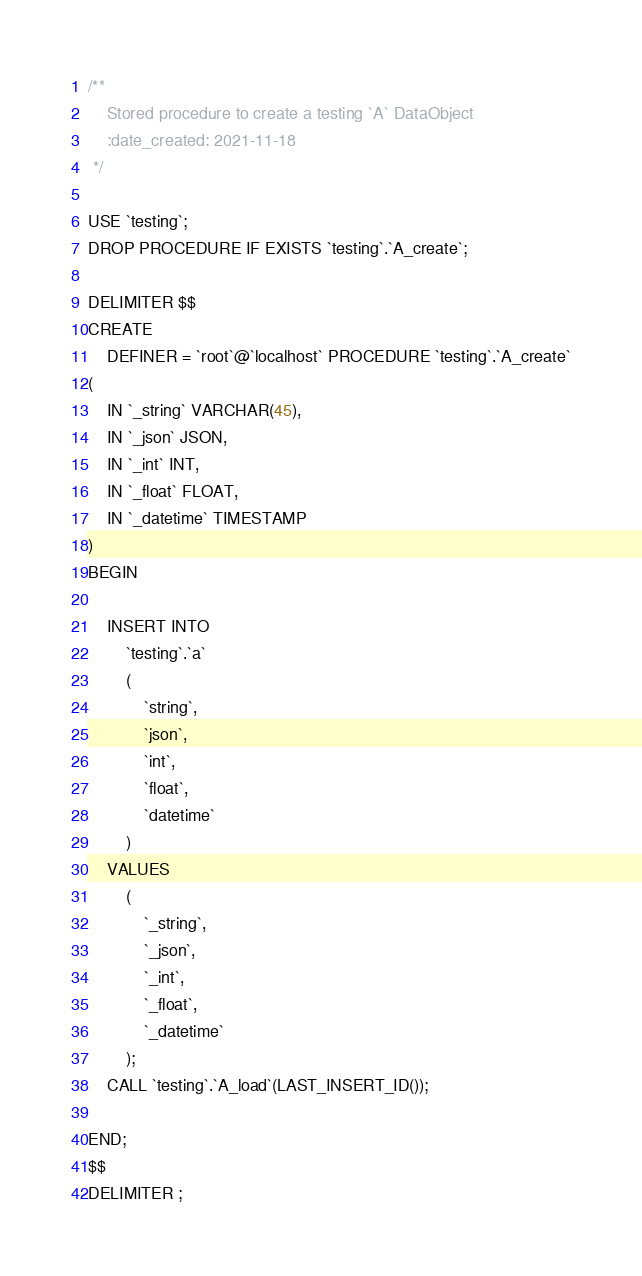Convert code to text. <code><loc_0><loc_0><loc_500><loc_500><_SQL_>/**
    Stored procedure to create a testing `A` DataObject
    :date_created: 2021-11-18
 */

USE `testing`;
DROP PROCEDURE IF EXISTS `testing`.`A_create`;

DELIMITER $$
CREATE
    DEFINER = `root`@`localhost` PROCEDURE `testing`.`A_create`
(
    IN `_string` VARCHAR(45),
    IN `_json` JSON,
    IN `_int` INT,
    IN `_float` FLOAT,
    IN `_datetime` TIMESTAMP
)
BEGIN

    INSERT INTO
        `testing`.`a`
        (
            `string`,
            `json`,
            `int`,
            `float`,
            `datetime`
        )
    VALUES
        (
            `_string`,
            `_json`,
            `_int`,
            `_float`,
            `_datetime`
        );
    CALL `testing`.`A_load`(LAST_INSERT_ID());

END;
$$
DELIMITER ;
</code> 